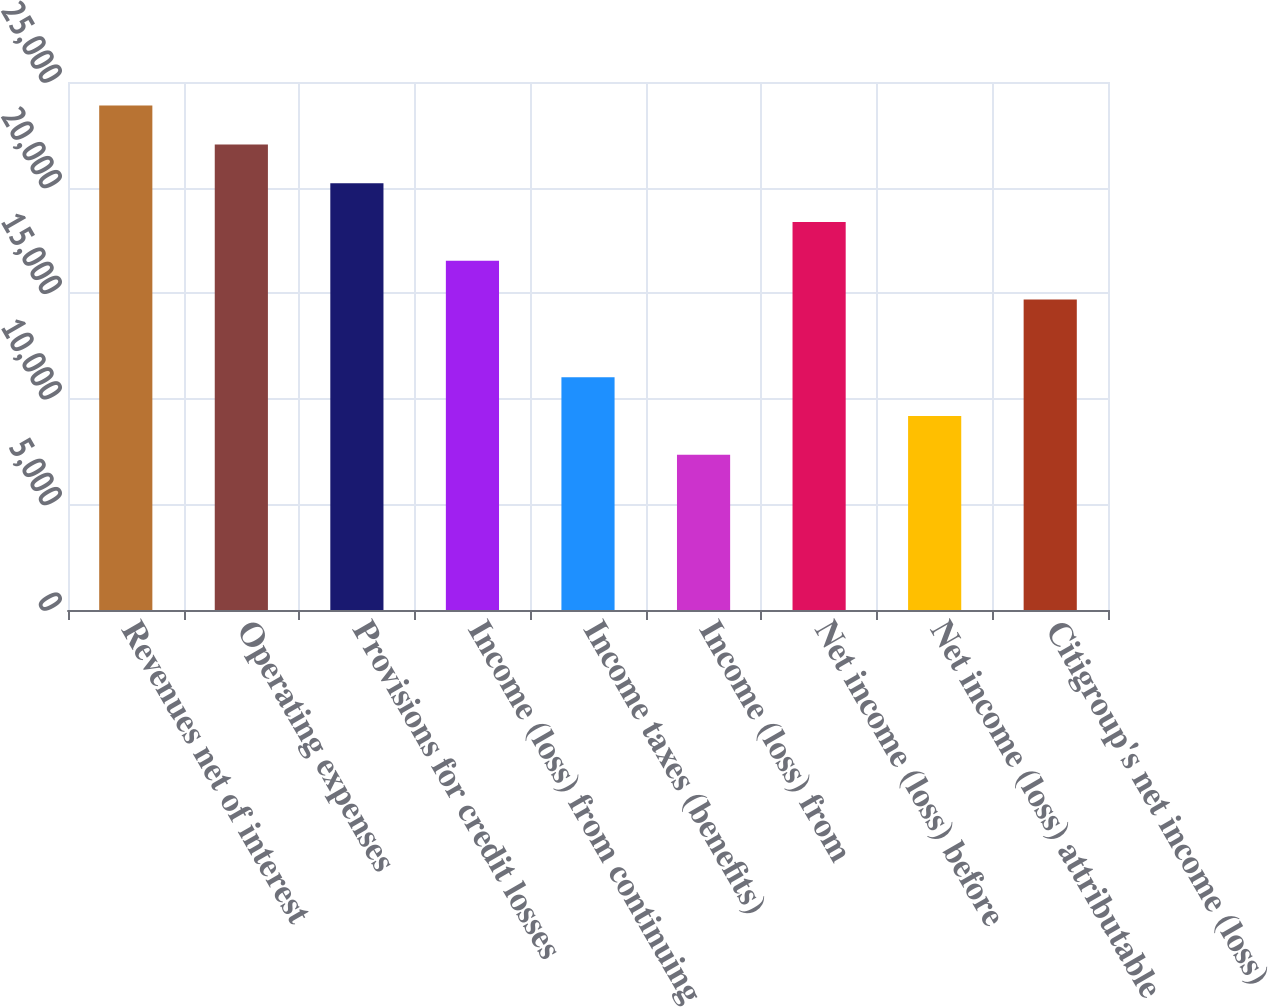Convert chart. <chart><loc_0><loc_0><loc_500><loc_500><bar_chart><fcel>Revenues net of interest<fcel>Operating expenses<fcel>Provisions for credit losses<fcel>Income (loss) from continuing<fcel>Income taxes (benefits)<fcel>Income (loss) from<fcel>Net income (loss) before<fcel>Net income (loss) attributable<fcel>Citigroup's net income (loss)<nl><fcel>23882.3<fcel>22045.2<fcel>20208.1<fcel>16533.9<fcel>11022.6<fcel>7348.44<fcel>18371<fcel>9185.54<fcel>14696.8<nl></chart> 